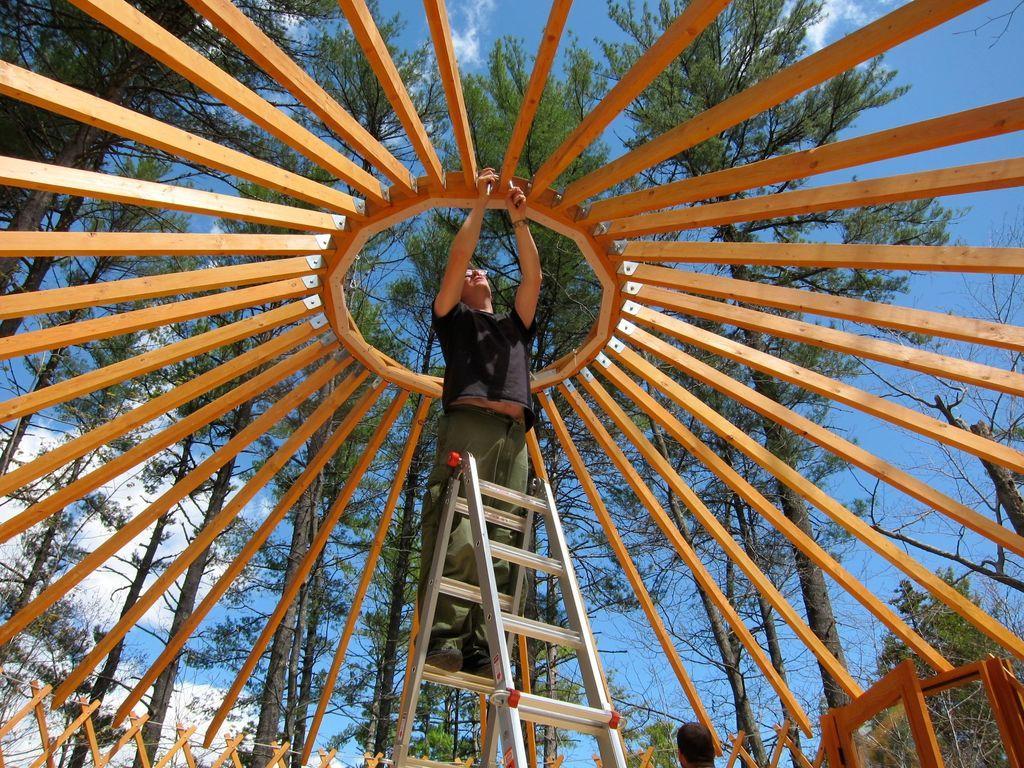Can you describe this image briefly? In this image, we can see a person on the ladder under wooden canopy. In the background, we can see some trees and sky. 